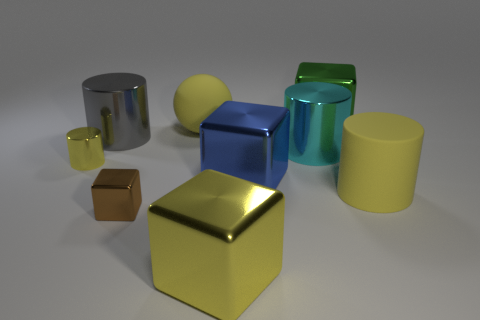Add 1 yellow shiny objects. How many objects exist? 10 Subtract all cyan cylinders. How many cylinders are left? 3 Subtract all big cyan shiny cylinders. How many cylinders are left? 3 Subtract 0 gray balls. How many objects are left? 9 Subtract all cubes. How many objects are left? 5 Subtract 3 blocks. How many blocks are left? 1 Subtract all red cubes. Subtract all cyan balls. How many cubes are left? 4 Subtract all blue balls. How many purple cylinders are left? 0 Subtract all large shiny cylinders. Subtract all metallic blocks. How many objects are left? 3 Add 3 big blue cubes. How many big blue cubes are left? 4 